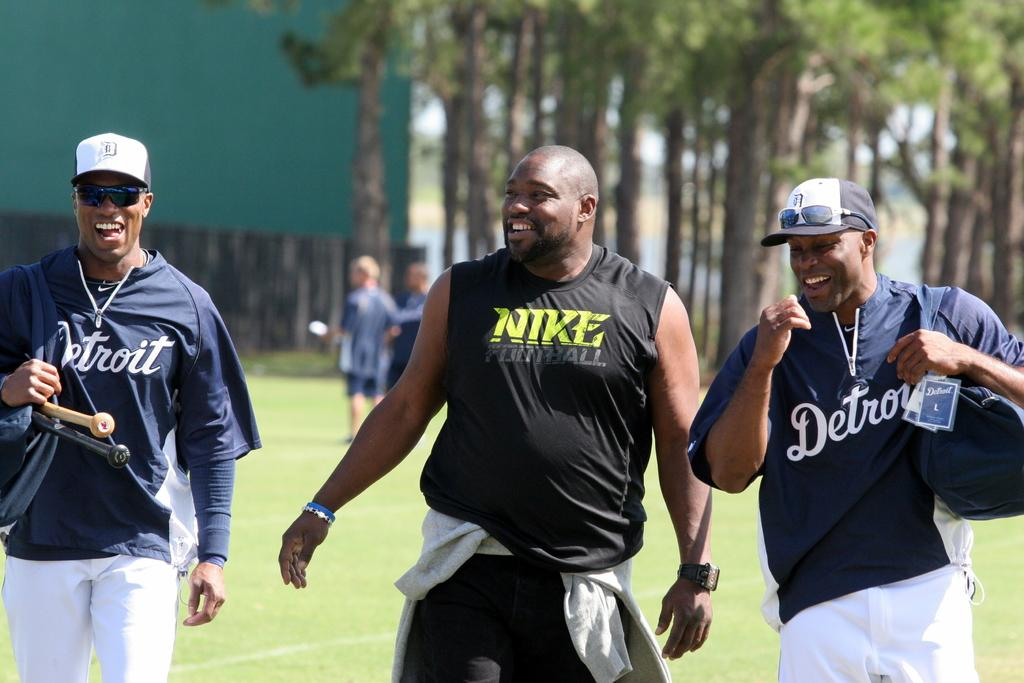<image>
Write a terse but informative summary of the picture. Some athletes wear ball caps and Detroit jerseys and another man is clad in a Nike Football tank.. 